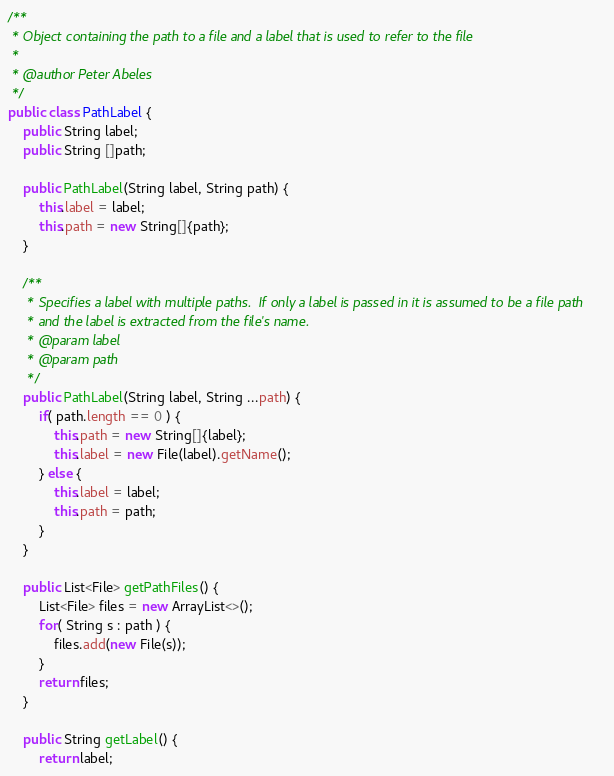Convert code to text. <code><loc_0><loc_0><loc_500><loc_500><_Java_>/**
 * Object containing the path to a file and a label that is used to refer to the file
 * 
 * @author Peter Abeles
 */
public class PathLabel {
	public String label;
	public String []path;

	public PathLabel(String label, String path) {
		this.label = label;
		this.path = new String[]{path};
	}

	/**
	 * Specifies a label with multiple paths.  If only a label is passed in it is assumed to be a file path
	 * and the label is extracted from the file's name.
	 * @param label
	 * @param path
	 */
	public PathLabel(String label, String ...path) {
		if( path.length == 0 ) {
			this.path = new String[]{label};
			this.label = new File(label).getName();
		} else {
			this.label = label;
			this.path = path;
		}
	}

	public List<File> getPathFiles() {
		List<File> files = new ArrayList<>();
		for( String s : path ) {
			files.add(new File(s));
		}
		return files;
	}

	public String getLabel() {
		return label;</code> 